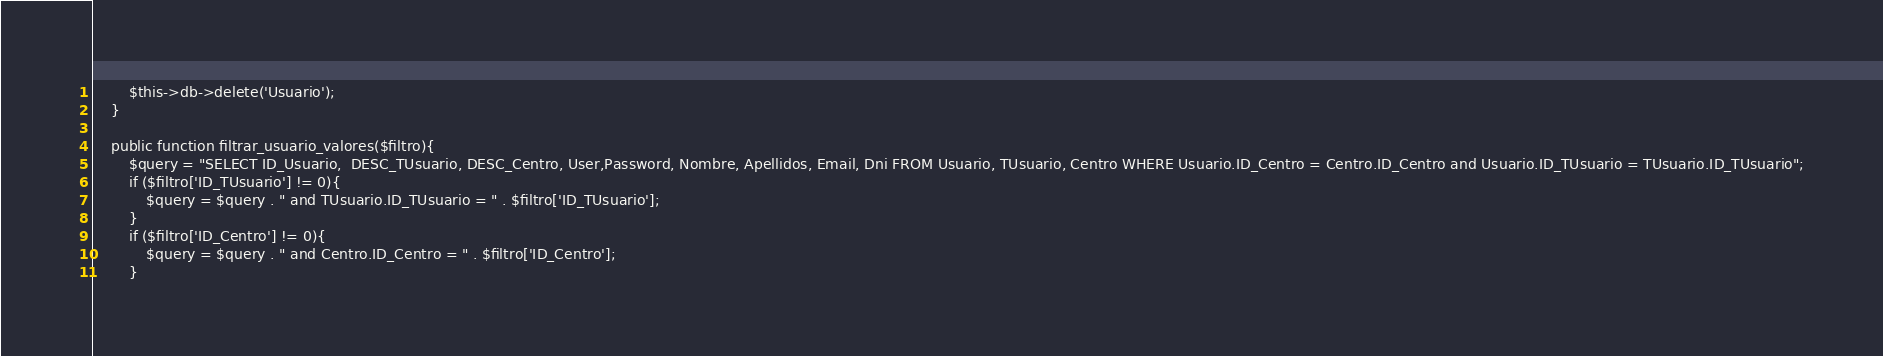<code> <loc_0><loc_0><loc_500><loc_500><_PHP_>		$this->db->delete('Usuario');
	}

	public function filtrar_usuario_valores($filtro){
		$query = "SELECT ID_Usuario,  DESC_TUsuario, DESC_Centro, User,Password, Nombre, Apellidos, Email, Dni FROM Usuario, TUsuario, Centro WHERE Usuario.ID_Centro = Centro.ID_Centro and Usuario.ID_TUsuario = TUsuario.ID_TUsuario";
		if ($filtro['ID_TUsuario'] != 0){
			$query = $query . " and TUsuario.ID_TUsuario = " . $filtro['ID_TUsuario'];
		}
		if ($filtro['ID_Centro'] != 0){
			$query = $query . " and Centro.ID_Centro = " . $filtro['ID_Centro'];
		}		</code> 